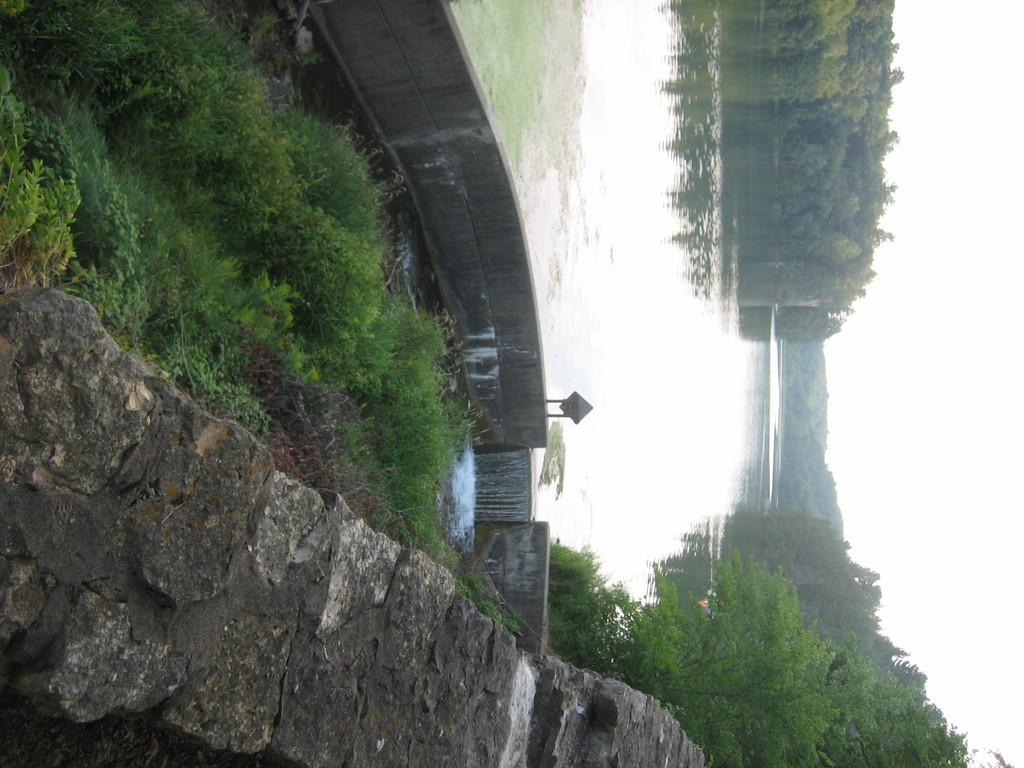Can you describe this image briefly? In the center of the image we can see a lake with water. In the foreground we can see a stone wall, sign board with some text. In the background, we can see a group of trees and the sky. 